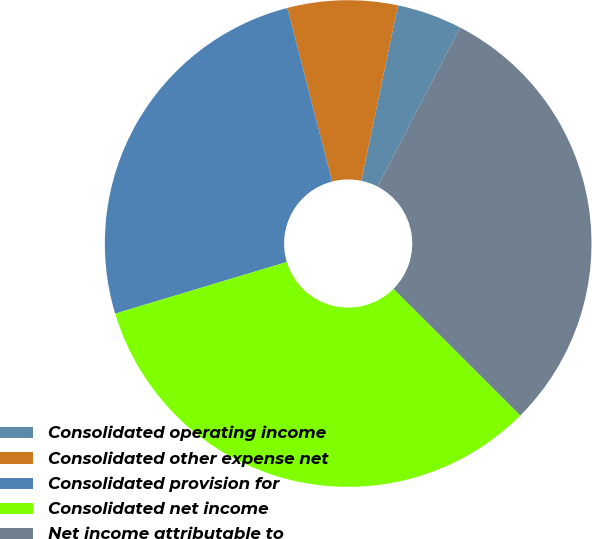Convert chart. <chart><loc_0><loc_0><loc_500><loc_500><pie_chart><fcel>Consolidated operating income<fcel>Consolidated other expense net<fcel>Consolidated provision for<fcel>Consolidated net income<fcel>Net income attributable to<nl><fcel>4.32%<fcel>7.31%<fcel>25.63%<fcel>32.86%<fcel>29.88%<nl></chart> 